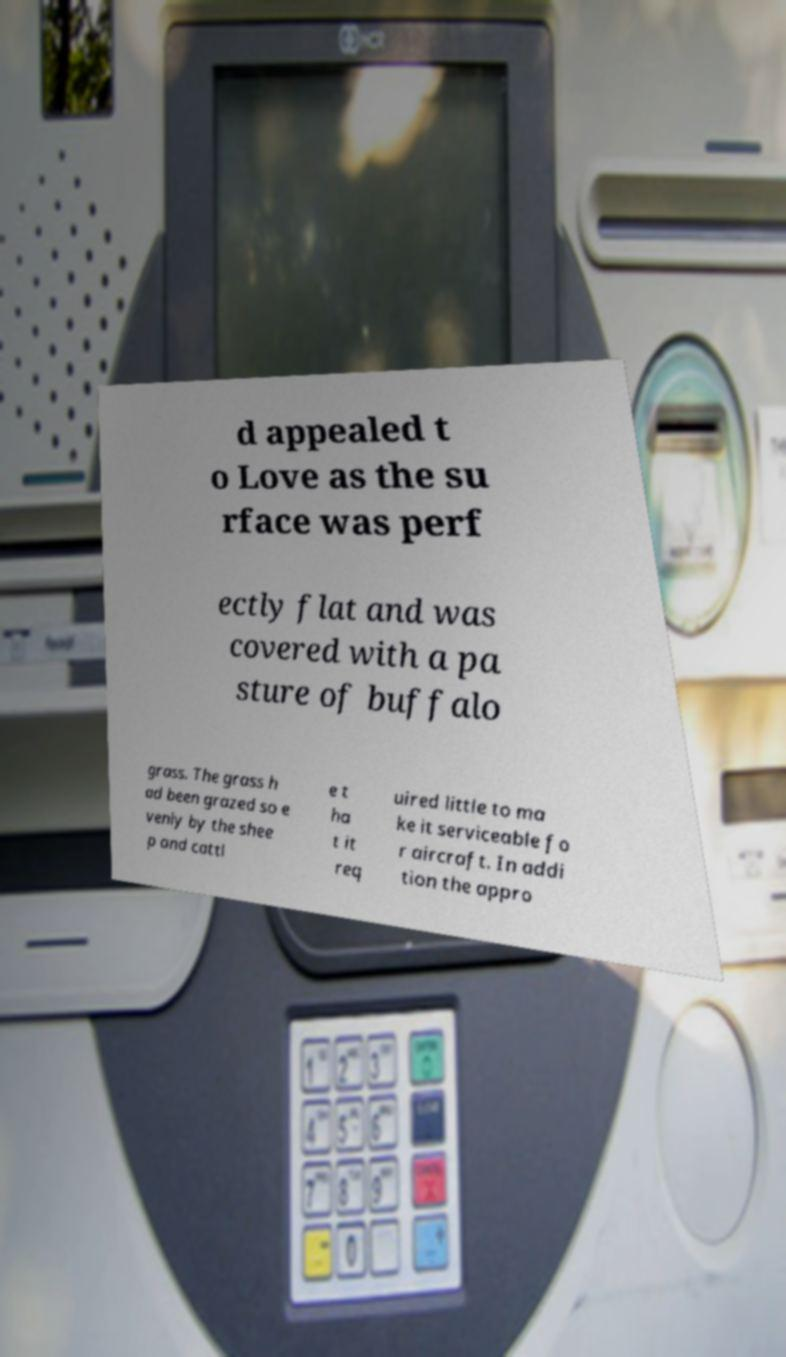Please identify and transcribe the text found in this image. d appealed t o Love as the su rface was perf ectly flat and was covered with a pa sture of buffalo grass. The grass h ad been grazed so e venly by the shee p and cattl e t ha t it req uired little to ma ke it serviceable fo r aircraft. In addi tion the appro 